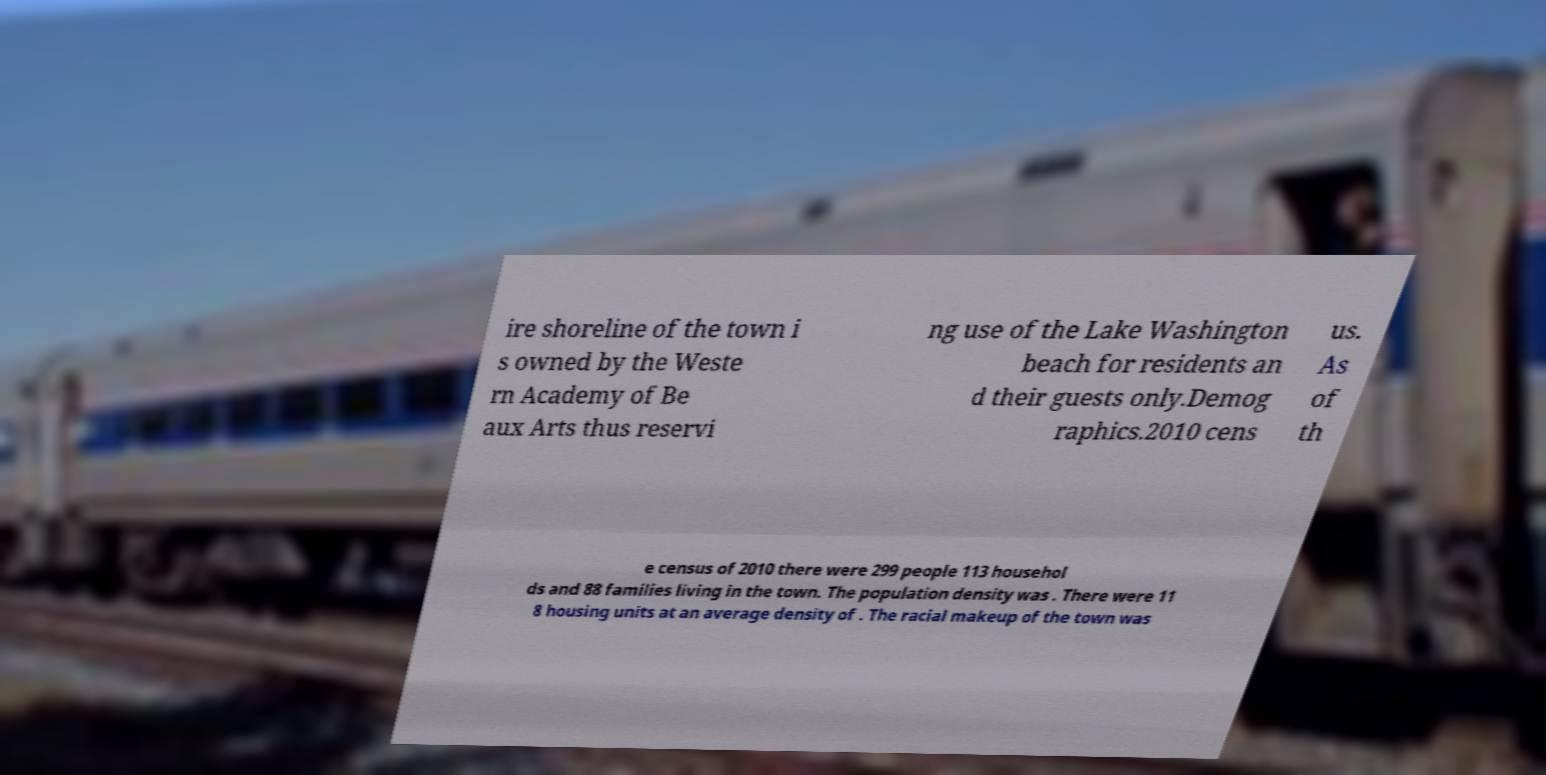What messages or text are displayed in this image? I need them in a readable, typed format. ire shoreline of the town i s owned by the Weste rn Academy of Be aux Arts thus reservi ng use of the Lake Washington beach for residents an d their guests only.Demog raphics.2010 cens us. As of th e census of 2010 there were 299 people 113 househol ds and 88 families living in the town. The population density was . There were 11 8 housing units at an average density of . The racial makeup of the town was 